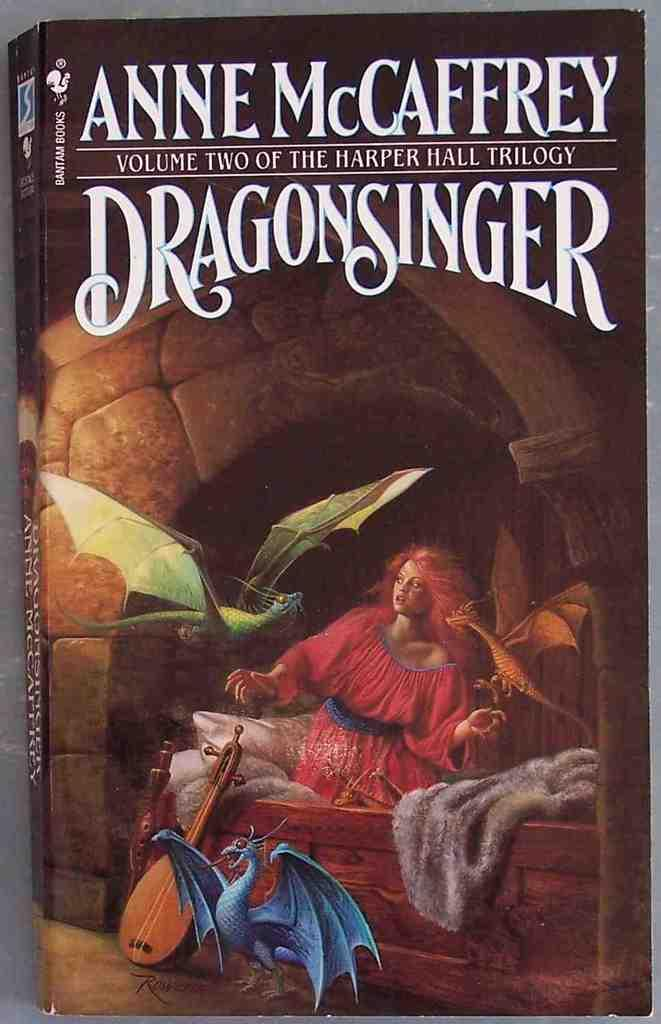<image>
Offer a succinct explanation of the picture presented. Book cover for Dragonsinger showing a woman with three dragons. 